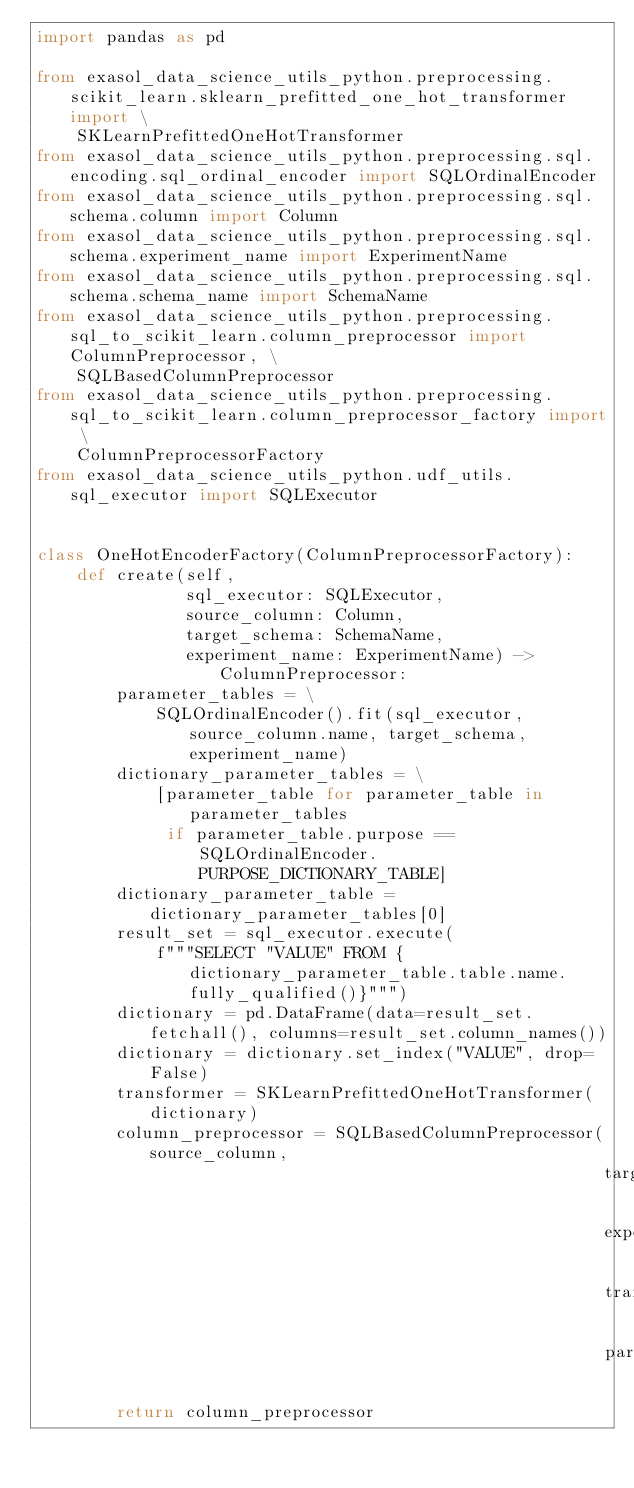Convert code to text. <code><loc_0><loc_0><loc_500><loc_500><_Python_>import pandas as pd

from exasol_data_science_utils_python.preprocessing.scikit_learn.sklearn_prefitted_one_hot_transformer import \
    SKLearnPrefittedOneHotTransformer
from exasol_data_science_utils_python.preprocessing.sql.encoding.sql_ordinal_encoder import SQLOrdinalEncoder
from exasol_data_science_utils_python.preprocessing.sql.schema.column import Column
from exasol_data_science_utils_python.preprocessing.sql.schema.experiment_name import ExperimentName
from exasol_data_science_utils_python.preprocessing.sql.schema.schema_name import SchemaName
from exasol_data_science_utils_python.preprocessing.sql_to_scikit_learn.column_preprocessor import ColumnPreprocessor, \
    SQLBasedColumnPreprocessor
from exasol_data_science_utils_python.preprocessing.sql_to_scikit_learn.column_preprocessor_factory import \
    ColumnPreprocessorFactory
from exasol_data_science_utils_python.udf_utils.sql_executor import SQLExecutor


class OneHotEncoderFactory(ColumnPreprocessorFactory):
    def create(self,
               sql_executor: SQLExecutor,
               source_column: Column,
               target_schema: SchemaName,
               experiment_name: ExperimentName) -> ColumnPreprocessor:
        parameter_tables = \
            SQLOrdinalEncoder().fit(sql_executor, source_column.name, target_schema, experiment_name)
        dictionary_parameter_tables = \
            [parameter_table for parameter_table in parameter_tables
             if parameter_table.purpose == SQLOrdinalEncoder.PURPOSE_DICTIONARY_TABLE]
        dictionary_parameter_table = dictionary_parameter_tables[0]
        result_set = sql_executor.execute(
            f"""SELECT "VALUE" FROM {dictionary_parameter_table.table.name.fully_qualified()}""")
        dictionary = pd.DataFrame(data=result_set.fetchall(), columns=result_set.column_names())
        dictionary = dictionary.set_index("VALUE", drop=False)
        transformer = SKLearnPrefittedOneHotTransformer(dictionary)
        column_preprocessor = SQLBasedColumnPreprocessor(source_column,
                                                         target_schema,
                                                         experiment_name,
                                                         transformer,
                                                         parameter_tables)
        return column_preprocessor
</code> 